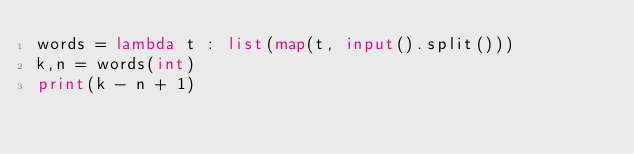<code> <loc_0><loc_0><loc_500><loc_500><_Python_>words = lambda t : list(map(t, input().split()))
k,n = words(int)
print(k - n + 1)
</code> 